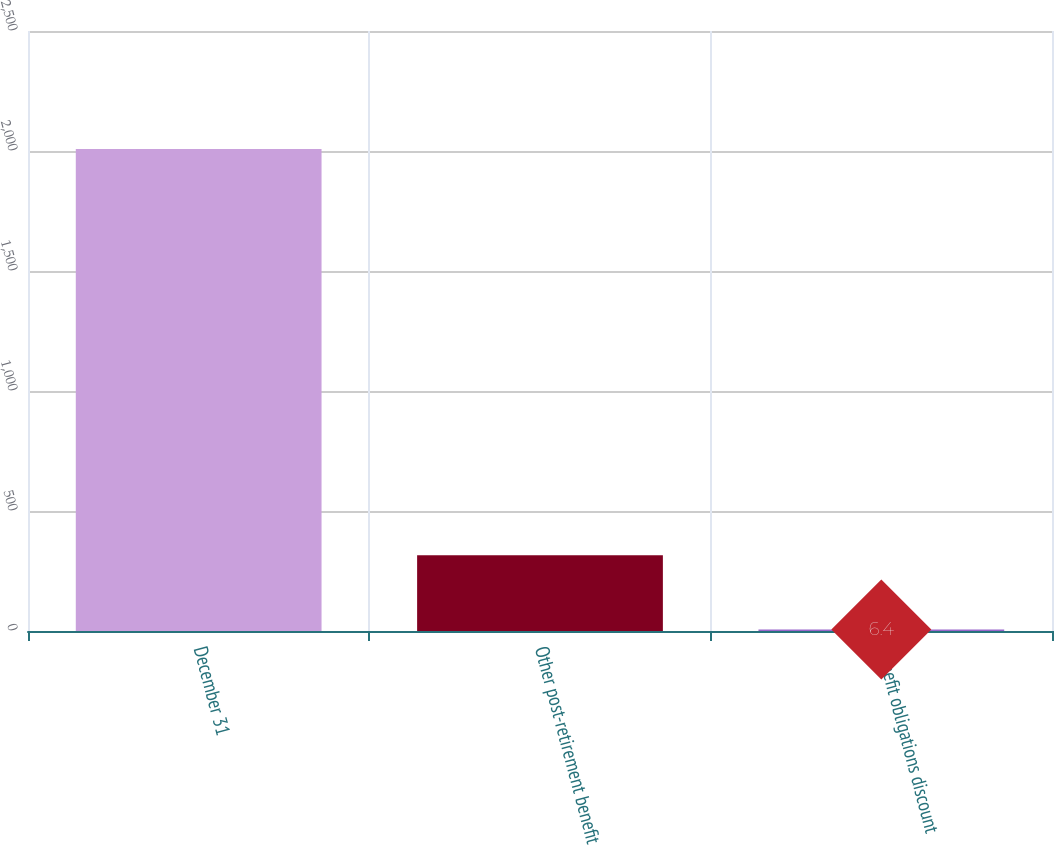<chart> <loc_0><loc_0><loc_500><loc_500><bar_chart><fcel>December 31<fcel>Other post-retirement benefit<fcel>Benefit obligations discount<nl><fcel>2008<fcel>315.4<fcel>6.4<nl></chart> 